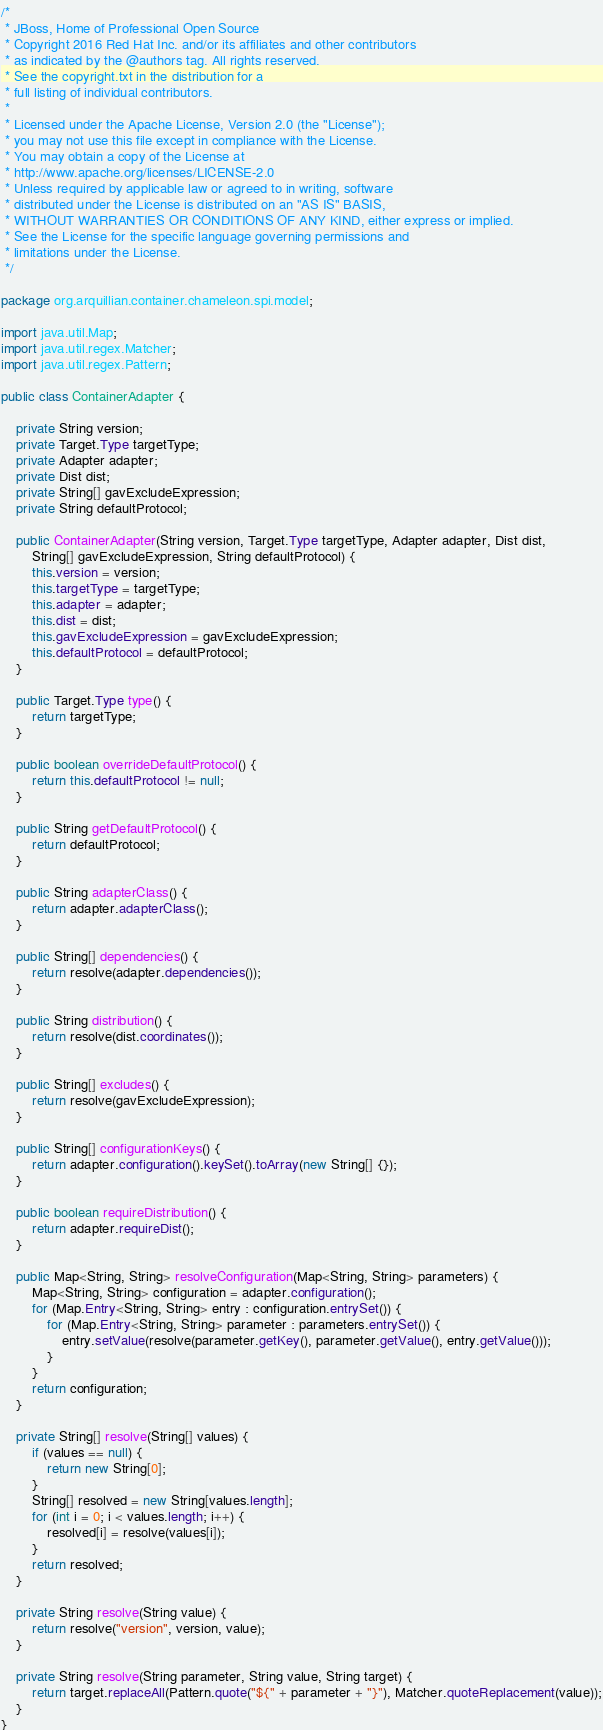Convert code to text. <code><loc_0><loc_0><loc_500><loc_500><_Java_>/*
 * JBoss, Home of Professional Open Source
 * Copyright 2016 Red Hat Inc. and/or its affiliates and other contributors
 * as indicated by the @authors tag. All rights reserved.
 * See the copyright.txt in the distribution for a
 * full listing of individual contributors.
 *
 * Licensed under the Apache License, Version 2.0 (the "License");
 * you may not use this file except in compliance with the License.
 * You may obtain a copy of the License at
 * http://www.apache.org/licenses/LICENSE-2.0
 * Unless required by applicable law or agreed to in writing, software
 * distributed under the License is distributed on an "AS IS" BASIS,
 * WITHOUT WARRANTIES OR CONDITIONS OF ANY KIND, either express or implied.
 * See the License for the specific language governing permissions and
 * limitations under the License.
 */

package org.arquillian.container.chameleon.spi.model;

import java.util.Map;
import java.util.regex.Matcher;
import java.util.regex.Pattern;

public class ContainerAdapter {

    private String version;
    private Target.Type targetType;
    private Adapter adapter;
    private Dist dist;
    private String[] gavExcludeExpression;
    private String defaultProtocol;

    public ContainerAdapter(String version, Target.Type targetType, Adapter adapter, Dist dist,
        String[] gavExcludeExpression, String defaultProtocol) {
        this.version = version;
        this.targetType = targetType;
        this.adapter = adapter;
        this.dist = dist;
        this.gavExcludeExpression = gavExcludeExpression;
        this.defaultProtocol = defaultProtocol;
    }

    public Target.Type type() {
        return targetType;
    }

    public boolean overrideDefaultProtocol() {
        return this.defaultProtocol != null;
    }

    public String getDefaultProtocol() {
        return defaultProtocol;
    }

    public String adapterClass() {
        return adapter.adapterClass();
    }

    public String[] dependencies() {
        return resolve(adapter.dependencies());
    }

    public String distribution() {
        return resolve(dist.coordinates());
    }

    public String[] excludes() {
        return resolve(gavExcludeExpression);
    }

    public String[] configurationKeys() {
        return adapter.configuration().keySet().toArray(new String[] {});
    }

    public boolean requireDistribution() {
        return adapter.requireDist();
    }

    public Map<String, String> resolveConfiguration(Map<String, String> parameters) {
        Map<String, String> configuration = adapter.configuration();
        for (Map.Entry<String, String> entry : configuration.entrySet()) {
            for (Map.Entry<String, String> parameter : parameters.entrySet()) {
                entry.setValue(resolve(parameter.getKey(), parameter.getValue(), entry.getValue()));
            }
        }
        return configuration;
    }

    private String[] resolve(String[] values) {
        if (values == null) {
            return new String[0];
        }
        String[] resolved = new String[values.length];
        for (int i = 0; i < values.length; i++) {
            resolved[i] = resolve(values[i]);
        }
        return resolved;
    }

    private String resolve(String value) {
        return resolve("version", version, value);
    }

    private String resolve(String parameter, String value, String target) {
        return target.replaceAll(Pattern.quote("${" + parameter + "}"), Matcher.quoteReplacement(value));
    }
}
</code> 